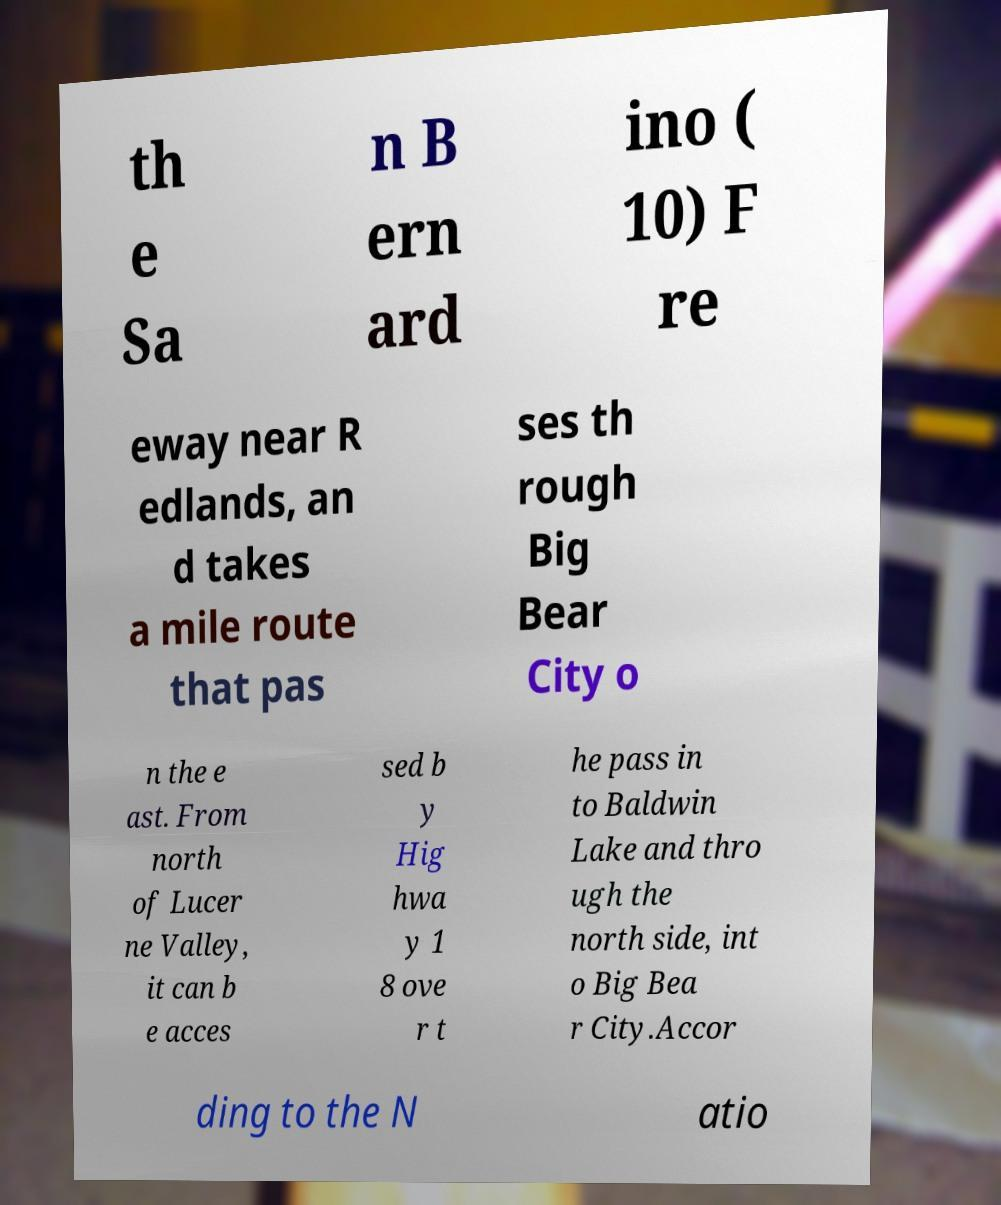Can you read and provide the text displayed in the image?This photo seems to have some interesting text. Can you extract and type it out for me? th e Sa n B ern ard ino ( 10) F re eway near R edlands, an d takes a mile route that pas ses th rough Big Bear City o n the e ast. From north of Lucer ne Valley, it can b e acces sed b y Hig hwa y 1 8 ove r t he pass in to Baldwin Lake and thro ugh the north side, int o Big Bea r City.Accor ding to the N atio 